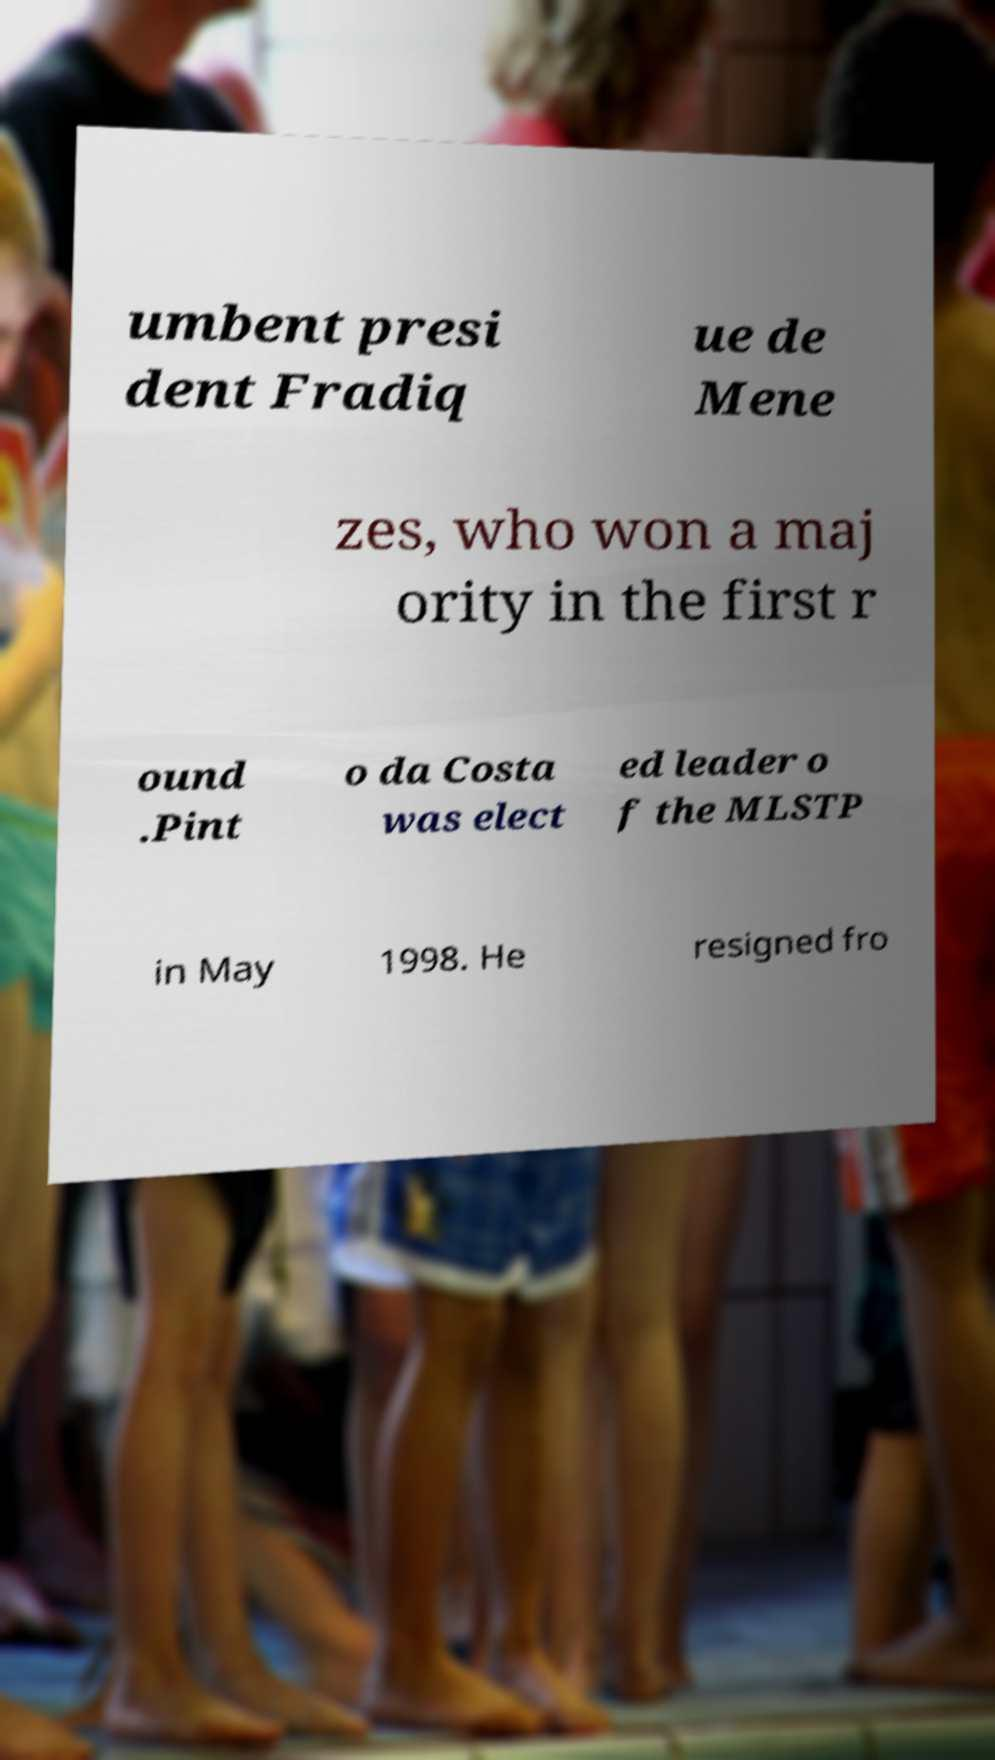I need the written content from this picture converted into text. Can you do that? umbent presi dent Fradiq ue de Mene zes, who won a maj ority in the first r ound .Pint o da Costa was elect ed leader o f the MLSTP in May 1998. He resigned fro 